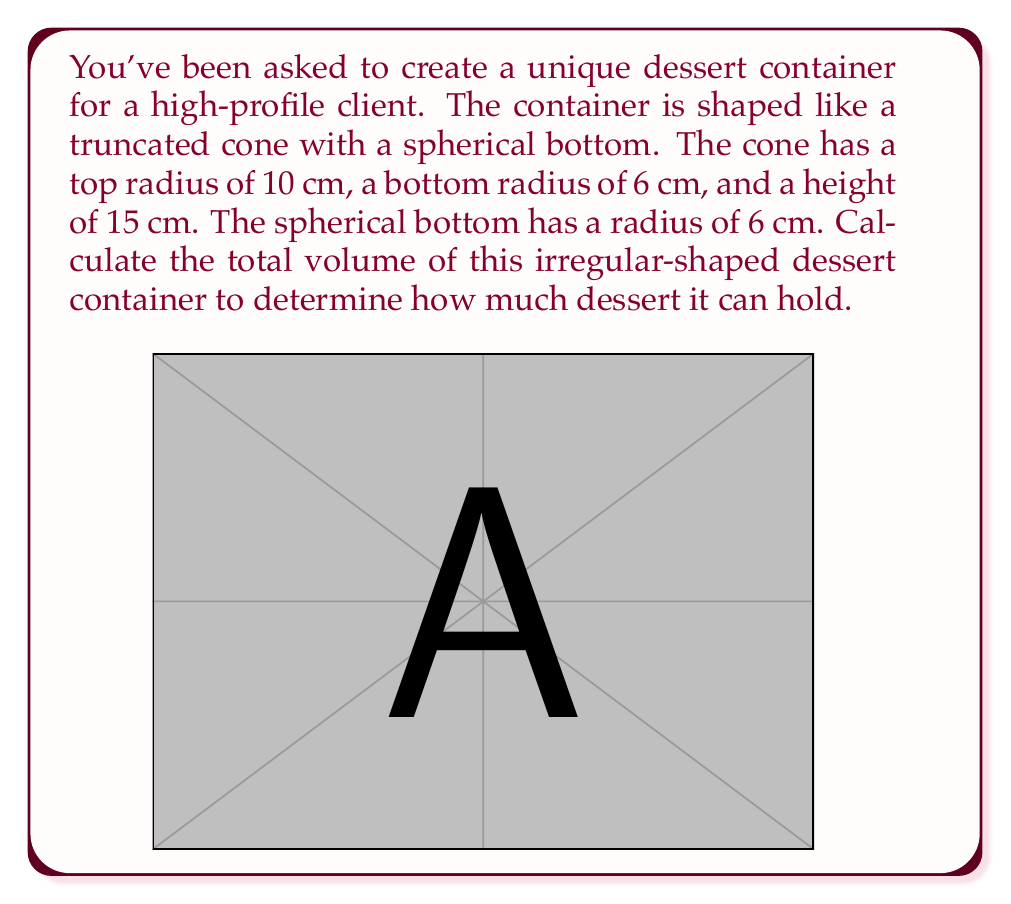Give your solution to this math problem. To solve this problem, we need to calculate the volumes of two parts separately and then add them together:

1. Volume of the truncated cone
2. Volume of the hemisphere (half of the spherical bottom)

1. Volume of the truncated cone:
The formula for the volume of a truncated cone is:

$$ V_{cone} = \frac{1}{3}\pi h(R^2 + r^2 + Rr) $$

Where:
$h$ = height of the cone = 15 cm
$R$ = radius of the top = 10 cm
$r$ = radius of the bottom = 6 cm

Substituting these values:

$$ V_{cone} = \frac{1}{3}\pi \cdot 15(10^2 + 6^2 + 10 \cdot 6) $$
$$ V_{cone} = 5\pi(100 + 36 + 60) $$
$$ V_{cone} = 5\pi \cdot 196 $$
$$ V_{cone} = 980\pi \approx 3079.20 \text{ cm}^3 $$

2. Volume of the hemisphere:
The formula for the volume of a sphere is $V_{sphere} = \frac{4}{3}\pi r^3$. We need half of this for the hemisphere:

$$ V_{hemisphere} = \frac{1}{2} \cdot \frac{4}{3}\pi r^3 = \frac{2}{3}\pi r^3 $$

Where $r = 6$ cm:

$$ V_{hemisphere} = \frac{2}{3}\pi \cdot 6^3 $$
$$ V_{hemisphere} = \frac{2}{3}\pi \cdot 216 $$
$$ V_{hemisphere} = 144\pi \approx 452.39 \text{ cm}^3 $$

3. Total volume:
The total volume is the sum of the truncated cone and the hemisphere:

$$ V_{total} = V_{cone} + V_{hemisphere} $$
$$ V_{total} = 980\pi + 144\pi $$
$$ V_{total} = 1124\pi \approx 3531.59 \text{ cm}^3 $$
Answer: The total volume of the irregular-shaped dessert container is $1124\pi \approx 3531.59 \text{ cm}^3$. 